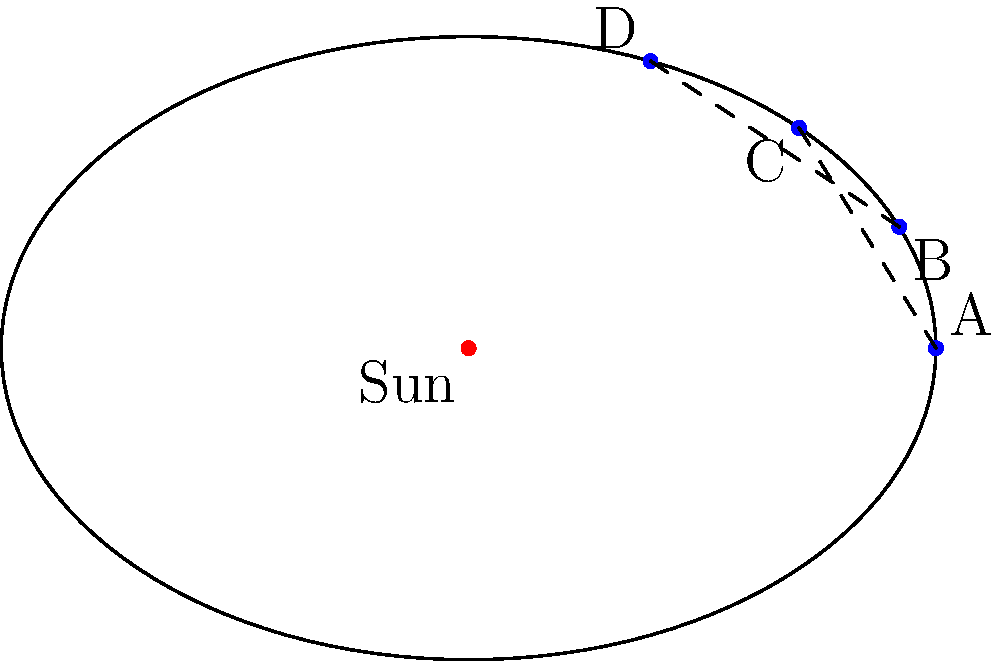As a 3PL broker managing the transportation of sensitive astronomical equipment, you're asked to coordinate a delivery that coincides with a comet's perihelion passage. The comet's orbit is shown in the diagram. At which point in its orbit will the comet be moving fastest, requiring extra care in equipment handling? To answer this question, we need to understand Kepler's laws of planetary motion, which also apply to comets:

1. Kepler's First Law: The orbit of a planet (or comet) around the Sun is an ellipse with the Sun at one of the two foci.

2. Kepler's Second Law: A line segment joining a planet (or comet) and the Sun sweeps out equal areas during equal intervals of time.

3. Kepler's Third Law: The square of the orbital period of a planet is directly proportional to the cube of the semi-major axis of its orbit.

In this case, we're particularly interested in Kepler's Second Law. This law implies that when an object is closer to the Sun, it moves faster to sweep out the same area in the same time as when it's farther away.

Looking at the diagram:

1. The Sun is at one focus of the elliptical orbit.
2. Point A is the closest point to the Sun (perihelion).
3. Point C is the farthest point from the Sun (aphelion).
4. Points B and D are at intermediate distances.

Because of Kepler's Second Law, the comet will be moving fastest at point A (perihelion) and slowest at point C (aphelion).

As a 3PL broker, you would need to schedule the delivery and handling of the astronomical equipment with extra care when the comet is at point A, as this is when it will be moving at its maximum velocity.
Answer: Point A (perihelion) 